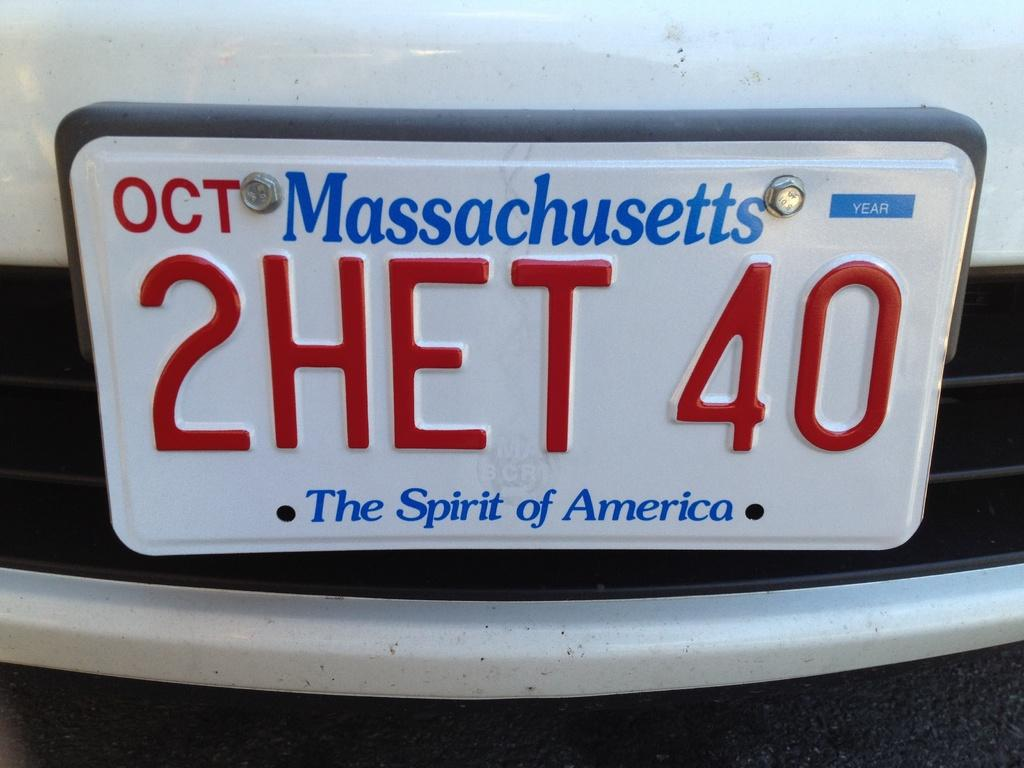<image>
Offer a succinct explanation of the picture presented. A Massachusetts license plate number reads 2HET 40. 